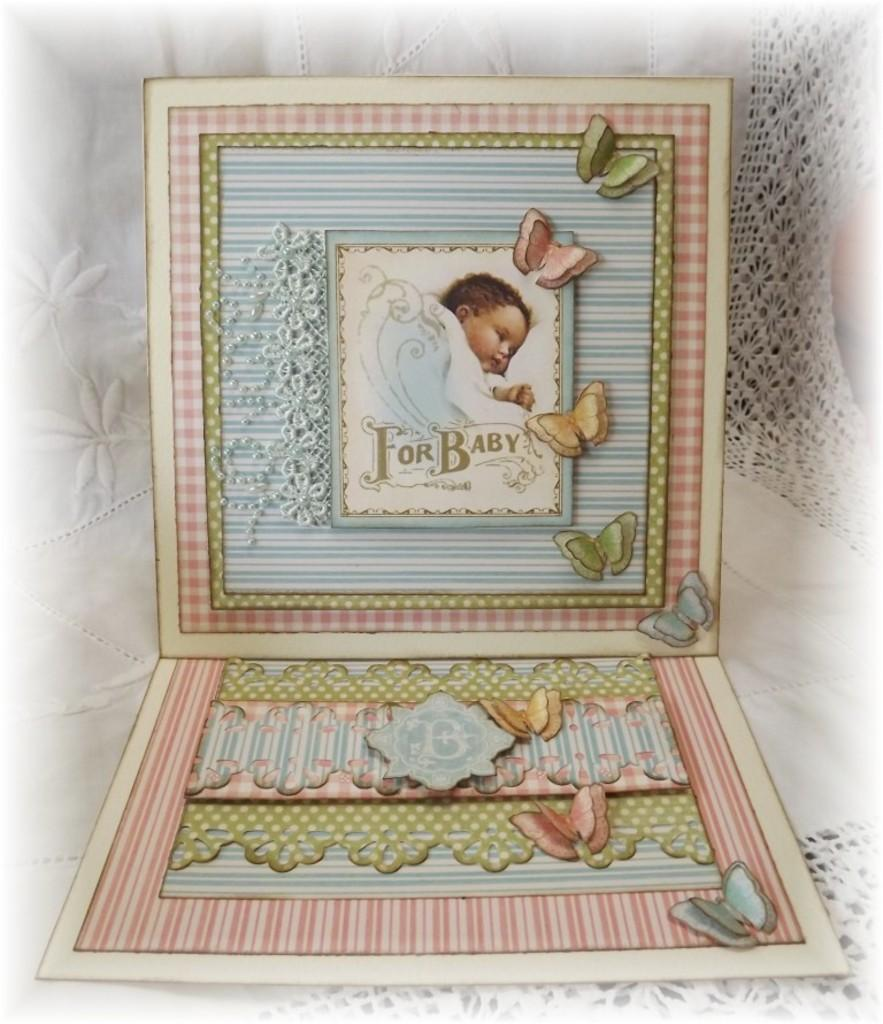Provide a one-sentence caption for the provided image. drawing of baby under a blanket with words 'for baby' on it surrounded by blue and pink patterns and butterflies. 